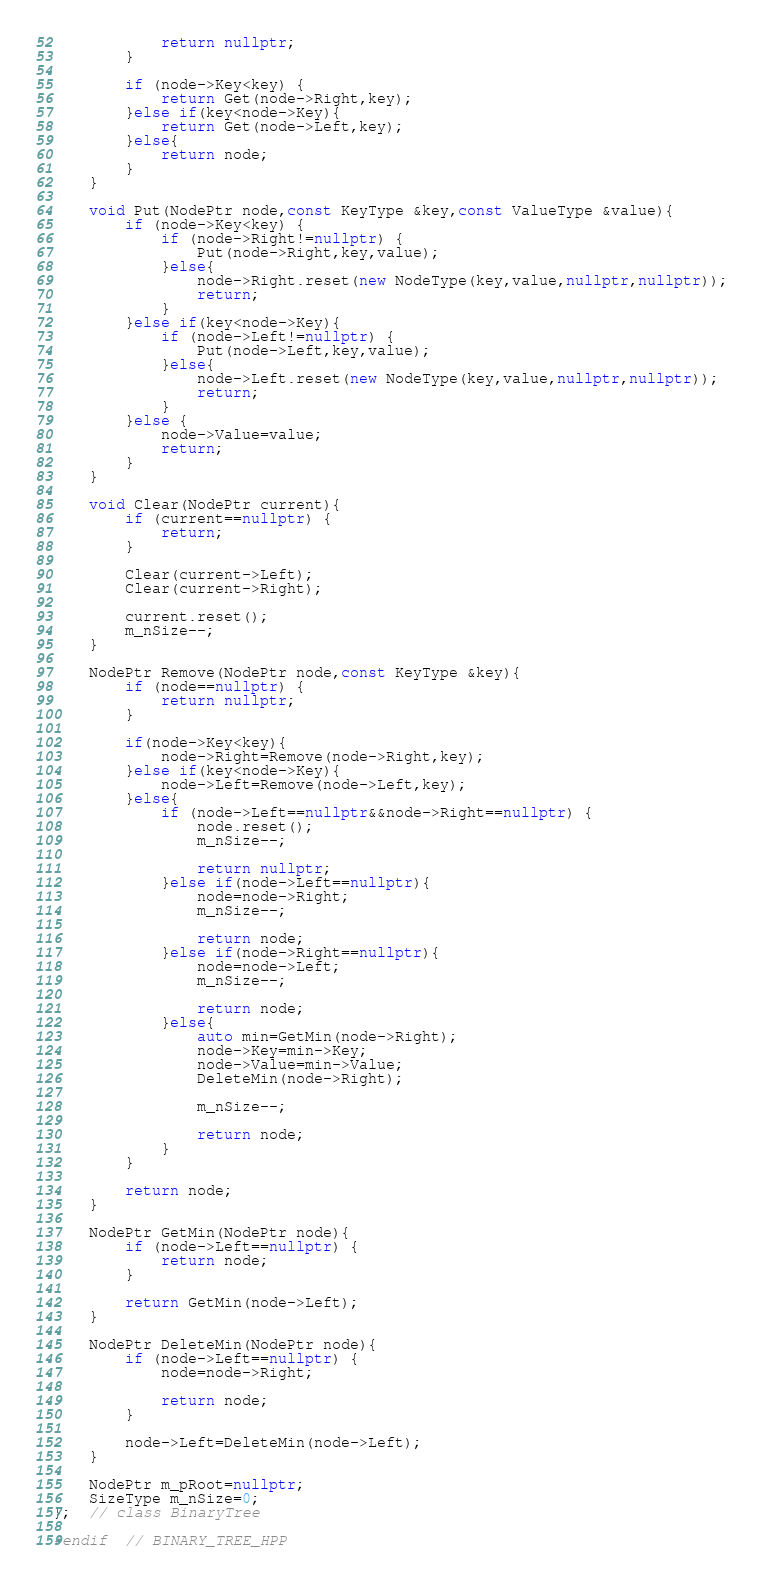Convert code to text. <code><loc_0><loc_0><loc_500><loc_500><_C++_>  		    return nullptr;
  		}

  		if (node->Key<key) {
  		    return Get(node->Right,key);
  		}else if(key<node->Key){
  			return Get(node->Left,key);
  		}else{
  			return node;
  		}
  	}

  	void Put(NodePtr node,const KeyType &key,const ValueType &value){
  		if (node->Key<key) {
  		    if (node->Right!=nullptr) {
  		        Put(node->Right,key,value);
  		    }else{
  		    	node->Right.reset(new NodeType(key,value,nullptr,nullptr));
  		    	return;
  		    }
  		}else if(key<node->Key){
  			if (node->Left!=nullptr) {
  			    Put(node->Left,key,value);
  			}else{
  				node->Left.reset(new NodeType(key,value,nullptr,nullptr));
  				return;
  			}
  		}else {
  		    node->Value=value;
  		    return;
  		}
  	}

  	void Clear(NodePtr current){
  		if (current==nullptr) {
  		    return;
  		}

  		Clear(current->Left);
  		Clear(current->Right);

  		current.reset();
  		m_nSize--;
  	}

  	NodePtr Remove(NodePtr node,const KeyType &key){
  		if (node==nullptr) {
  		    return nullptr;
  		}

  		if(node->Key<key){
			node->Right=Remove(node->Right,key);
  		}else if(key<node->Key){
  			node->Left=Remove(node->Left,key);
  		}else{
  			if (node->Left==nullptr&&node->Right==nullptr) {
  			    node.reset();
  			    m_nSize--;

  			    return nullptr;
  			}else if(node->Left==nullptr){
                node=node->Right;
  				m_nSize--;

  				return node;
  			}else if(node->Right==nullptr){
                node=node->Left;
                m_nSize--;

                return node;
  			}else{
  				auto min=GetMin(node->Right);
  				node->Key=min->Key;
  				node->Value=min->Value;
  				DeleteMin(node->Right);

  				m_nSize--;

  				return node;
  			}
  		}

  		return node;
  	}

  	NodePtr GetMin(NodePtr node){
  		if (node->Left==nullptr) {
  		    return node;
  		}

  		return GetMin(node->Left);
  	}

  	NodePtr DeleteMin(NodePtr node){
  		if (node->Left==nullptr) {
            node=node->Right;

  		    return node;
  		}

  		node->Left=DeleteMin(node->Left);
  	}

    NodePtr m_pRoot=nullptr;
    SizeType m_nSize=0;
};  // class BinaryTree
    
#endif  // BINARY_TREE_HPP
</code> 